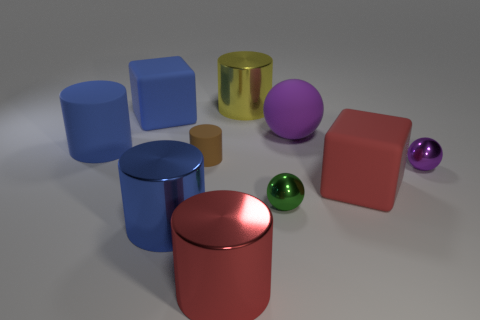Subtract 1 cylinders. How many cylinders are left? 4 Subtract all brown rubber cylinders. How many cylinders are left? 4 Subtract all brown cylinders. How many cylinders are left? 4 Subtract all gray cylinders. Subtract all yellow cubes. How many cylinders are left? 5 Add 4 large cyan metal cylinders. How many large cyan metal cylinders exist? 4 Subtract 0 purple cylinders. How many objects are left? 10 Subtract all spheres. How many objects are left? 7 Subtract all small cylinders. Subtract all green balls. How many objects are left? 8 Add 5 large yellow things. How many large yellow things are left? 6 